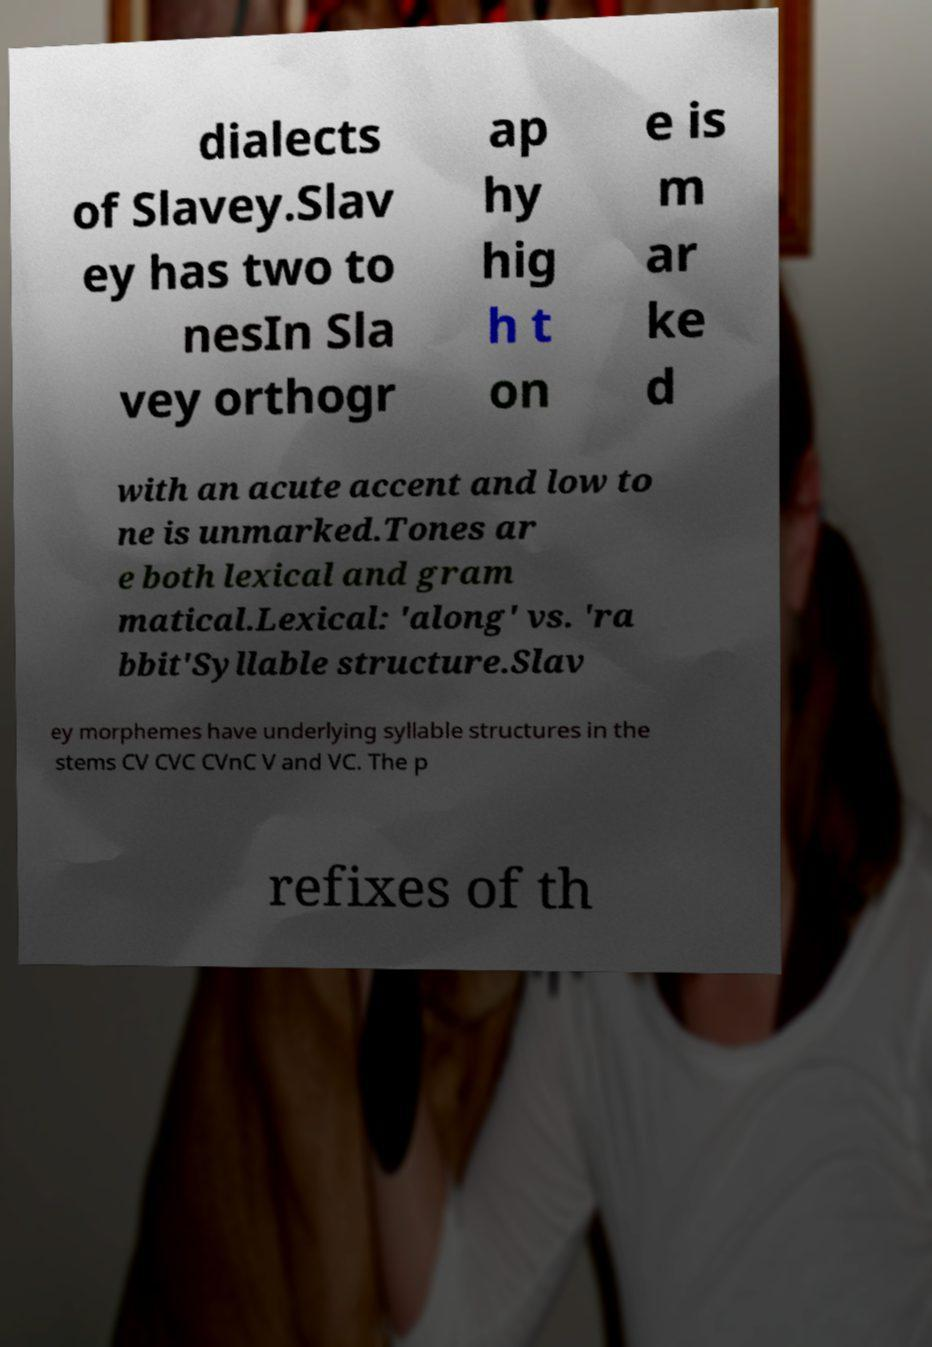Could you extract and type out the text from this image? dialects of Slavey.Slav ey has two to nesIn Sla vey orthogr ap hy hig h t on e is m ar ke d with an acute accent and low to ne is unmarked.Tones ar e both lexical and gram matical.Lexical: 'along' vs. 'ra bbit'Syllable structure.Slav ey morphemes have underlying syllable structures in the stems CV CVC CVnC V and VC. The p refixes of th 